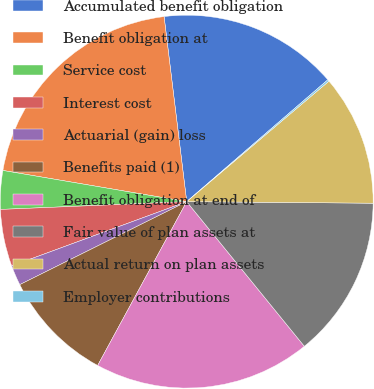<chart> <loc_0><loc_0><loc_500><loc_500><pie_chart><fcel>Accumulated benefit obligation<fcel>Benefit obligation at<fcel>Service cost<fcel>Interest cost<fcel>Actuarial (gain) loss<fcel>Benefits paid (1)<fcel>Benefit obligation at end of<fcel>Fair value of plan assets at<fcel>Actual return on plan assets<fcel>Employer contributions<nl><fcel>15.6%<fcel>20.39%<fcel>3.34%<fcel>4.94%<fcel>1.74%<fcel>9.73%<fcel>18.79%<fcel>14.0%<fcel>11.32%<fcel>0.15%<nl></chart> 